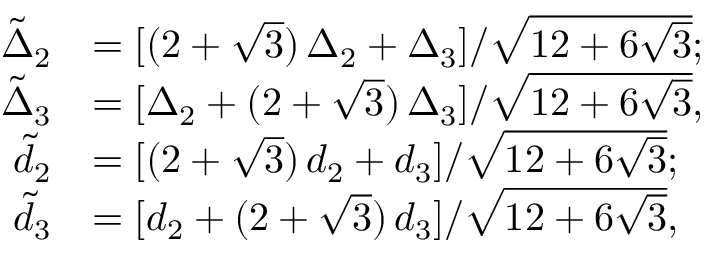Convert formula to latex. <formula><loc_0><loc_0><loc_500><loc_500>\begin{array} { r l } { \tilde { \Delta } _ { 2 } } & { = [ ( 2 + \sqrt { 3 } ) \, \Delta _ { 2 } + \Delta _ { 3 } ] / \sqrt { 1 2 + 6 \sqrt { 3 } } ; } \\ { \tilde { \Delta } _ { 3 } } & { = [ \Delta _ { 2 } + ( 2 + \sqrt { 3 } ) \, \Delta _ { 3 } ] / \sqrt { 1 2 + 6 \sqrt { 3 } } , } \\ { \tilde { d } _ { 2 } } & { = [ ( 2 + \sqrt { 3 } ) \, d _ { 2 } + d _ { 3 } ] / \sqrt { 1 2 + 6 \sqrt { 3 } } ; } \\ { \tilde { d } _ { 3 } } & { = [ d _ { 2 } + ( 2 + \sqrt { 3 } ) \, d _ { 3 } ] / \sqrt { 1 2 + 6 \sqrt { 3 } } , } \end{array}</formula> 